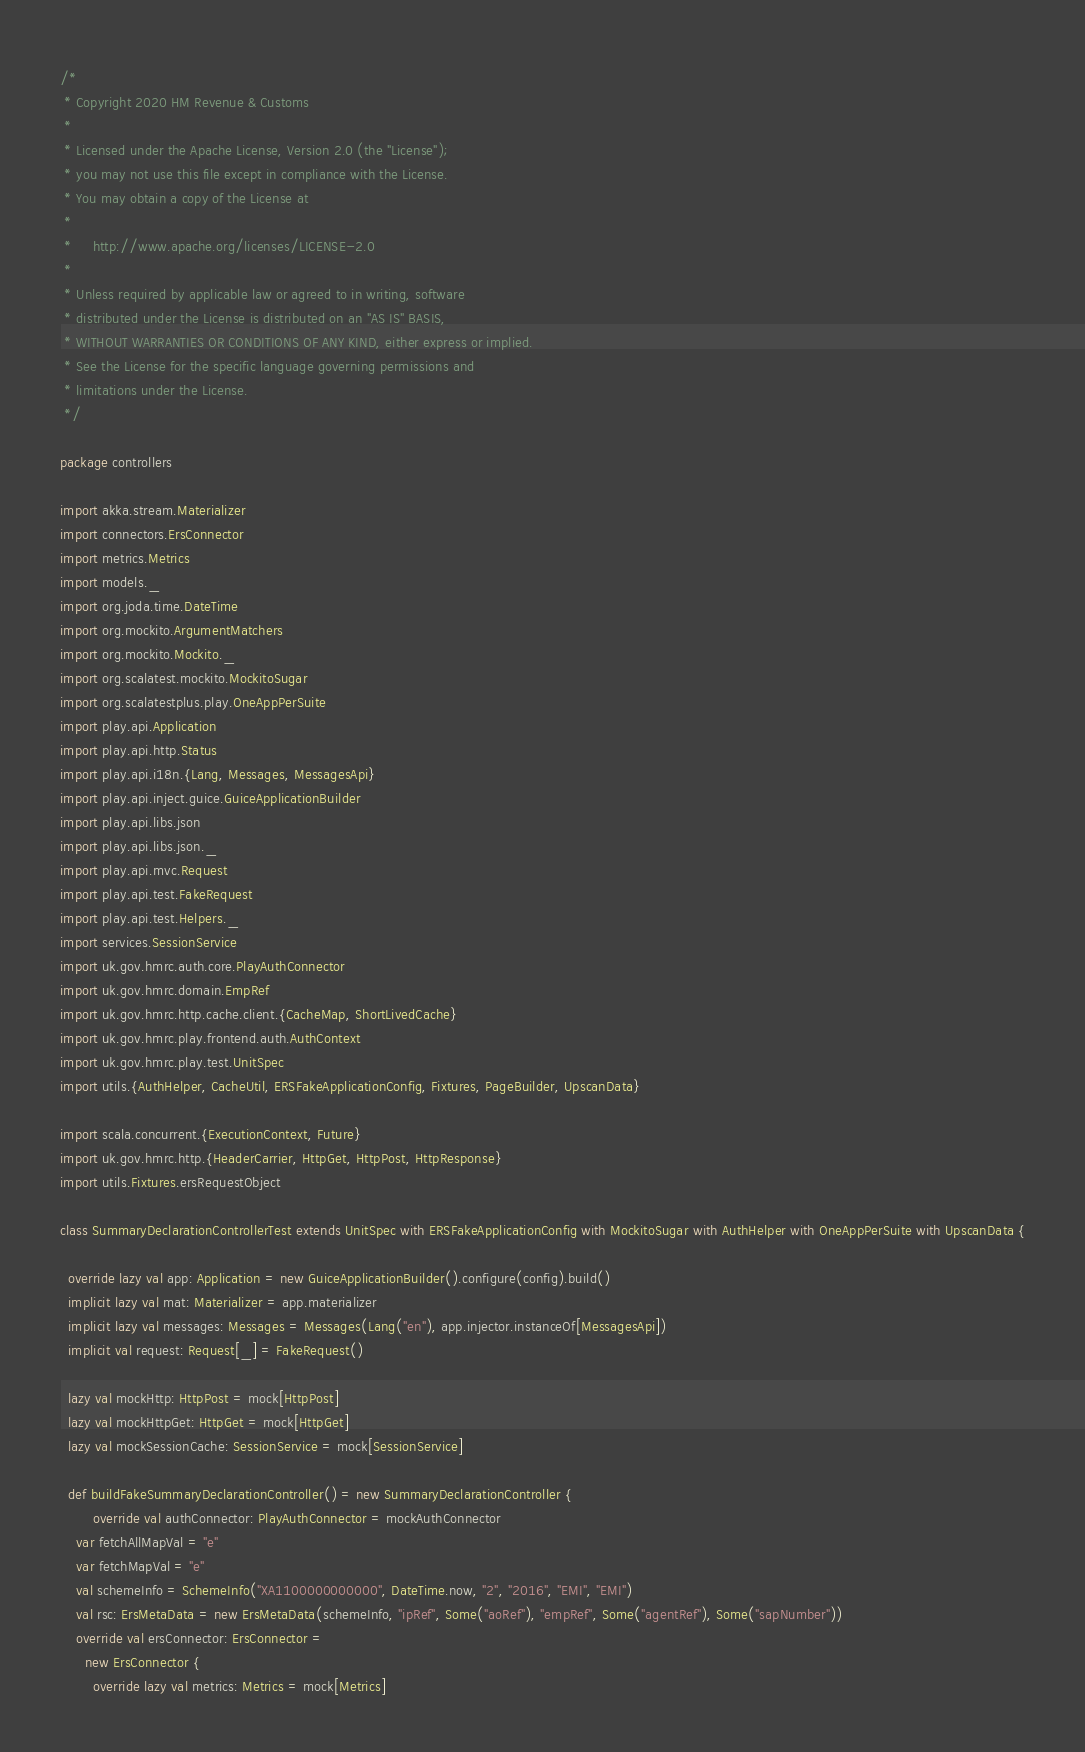<code> <loc_0><loc_0><loc_500><loc_500><_Scala_>/*
 * Copyright 2020 HM Revenue & Customs
 *
 * Licensed under the Apache License, Version 2.0 (the "License");
 * you may not use this file except in compliance with the License.
 * You may obtain a copy of the License at
 *
 *     http://www.apache.org/licenses/LICENSE-2.0
 *
 * Unless required by applicable law or agreed to in writing, software
 * distributed under the License is distributed on an "AS IS" BASIS,
 * WITHOUT WARRANTIES OR CONDITIONS OF ANY KIND, either express or implied.
 * See the License for the specific language governing permissions and
 * limitations under the License.
 */

package controllers

import akka.stream.Materializer
import connectors.ErsConnector
import metrics.Metrics
import models._
import org.joda.time.DateTime
import org.mockito.ArgumentMatchers
import org.mockito.Mockito._
import org.scalatest.mockito.MockitoSugar
import org.scalatestplus.play.OneAppPerSuite
import play.api.Application
import play.api.http.Status
import play.api.i18n.{Lang, Messages, MessagesApi}
import play.api.inject.guice.GuiceApplicationBuilder
import play.api.libs.json
import play.api.libs.json._
import play.api.mvc.Request
import play.api.test.FakeRequest
import play.api.test.Helpers._
import services.SessionService
import uk.gov.hmrc.auth.core.PlayAuthConnector
import uk.gov.hmrc.domain.EmpRef
import uk.gov.hmrc.http.cache.client.{CacheMap, ShortLivedCache}
import uk.gov.hmrc.play.frontend.auth.AuthContext
import uk.gov.hmrc.play.test.UnitSpec
import utils.{AuthHelper, CacheUtil, ERSFakeApplicationConfig, Fixtures, PageBuilder, UpscanData}

import scala.concurrent.{ExecutionContext, Future}
import uk.gov.hmrc.http.{HeaderCarrier, HttpGet, HttpPost, HttpResponse}
import utils.Fixtures.ersRequestObject

class SummaryDeclarationControllerTest extends UnitSpec with ERSFakeApplicationConfig with MockitoSugar with AuthHelper with OneAppPerSuite with UpscanData {

  override lazy val app: Application = new GuiceApplicationBuilder().configure(config).build()
  implicit lazy val mat: Materializer = app.materializer
  implicit lazy val messages: Messages = Messages(Lang("en"), app.injector.instanceOf[MessagesApi])
  implicit val request: Request[_] = FakeRequest()

  lazy val mockHttp: HttpPost = mock[HttpPost]
  lazy val mockHttpGet: HttpGet = mock[HttpGet]
  lazy val mockSessionCache: SessionService = mock[SessionService]

  def buildFakeSummaryDeclarationController() = new SummaryDeclarationController {
		override val authConnector: PlayAuthConnector = mockAuthConnector
    var fetchAllMapVal = "e"
    var fetchMapVal = "e"
    val schemeInfo = SchemeInfo("XA1100000000000", DateTime.now, "2", "2016", "EMI", "EMI")
    val rsc: ErsMetaData = new ErsMetaData(schemeInfo, "ipRef", Some("aoRef"), "empRef", Some("agentRef"), Some("sapNumber"))
    override val ersConnector: ErsConnector =
      new ErsConnector {
        override lazy val metrics: Metrics = mock[Metrics]
</code> 